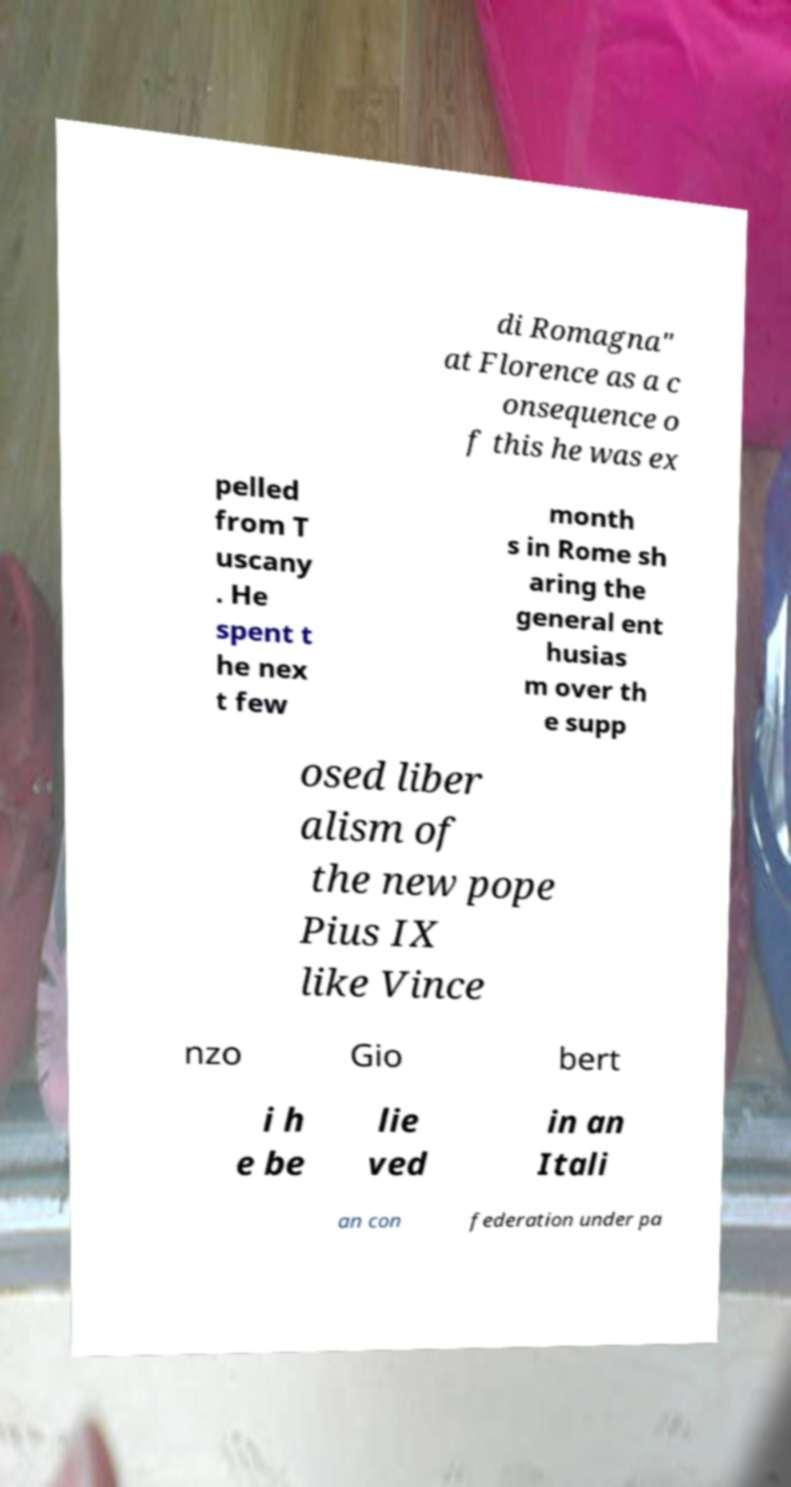Can you read and provide the text displayed in the image?This photo seems to have some interesting text. Can you extract and type it out for me? di Romagna" at Florence as a c onsequence o f this he was ex pelled from T uscany . He spent t he nex t few month s in Rome sh aring the general ent husias m over th e supp osed liber alism of the new pope Pius IX like Vince nzo Gio bert i h e be lie ved in an Itali an con federation under pa 